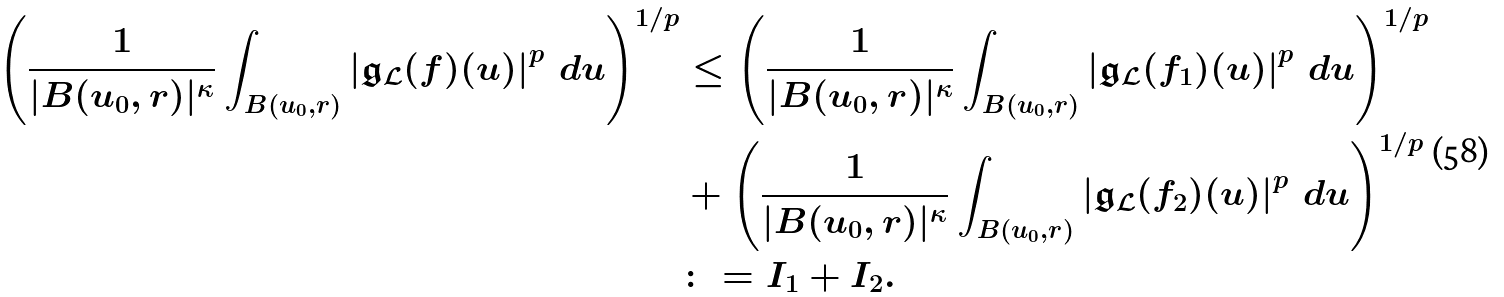<formula> <loc_0><loc_0><loc_500><loc_500>\left ( \frac { 1 } { | B ( u _ { 0 } , r ) | ^ { \kappa } } \int _ { B ( u _ { 0 } , r ) } \left | \mathfrak { g } _ { \mathcal { L } } ( f ) ( u ) \right | ^ { p } \, d u \right ) ^ { 1 / p } & \leq \left ( \frac { 1 } { | B ( u _ { 0 } , r ) | ^ { \kappa } } \int _ { B ( u _ { 0 } , r ) } \left | \mathfrak { g } _ { \mathcal { L } } ( f _ { 1 } ) ( u ) \right | ^ { p } \, d u \right ) ^ { 1 / p } \\ & + \left ( \frac { 1 } { | B ( u _ { 0 } , r ) | ^ { \kappa } } \int _ { B ( u _ { 0 } , r ) } \left | \mathfrak { g } _ { \mathcal { L } } ( f _ { 2 } ) ( u ) \right | ^ { p } \, d u \right ) ^ { 1 / p } \\ & \colon = I _ { 1 } + I _ { 2 } .</formula> 